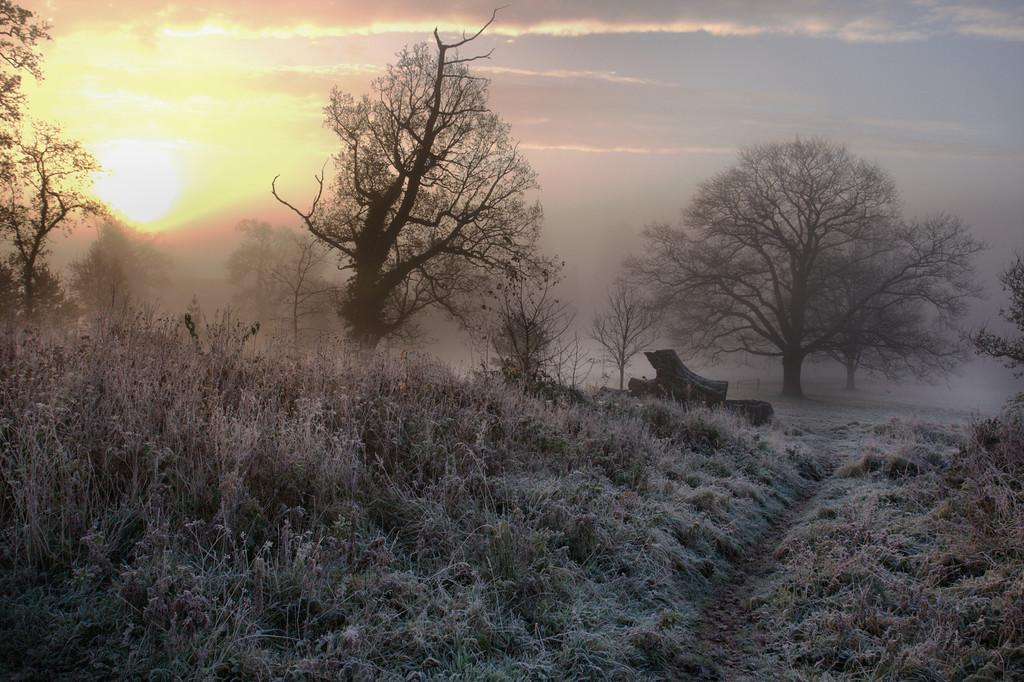What type of vegetation can be seen in the image? There is grass, plants, and trees visible in the image. What material are the logs made of in the image? The logs in the image are made of wood. What is visible in the background of the image? The sky, the sun, and trees are visible in the background of the image. What month is it in the image? The month cannot be determined from the image, as there is no information about the time of year. Can you see a harbor in the image? There is no harbor present in the image. Is there a porter carrying luggage in the image? There is no porter or luggage present in the image. 